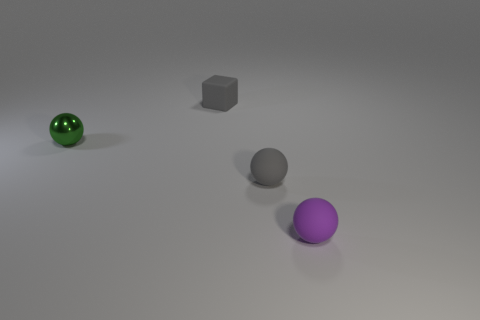How are the shadows affecting the perception of the objects? The shadows cast by the objects help to give a sense of their three-dimensionality and position in the space. They provide clues about the light source direction, which seems to be coming from the top left, and add depth to the image, enhancing the perception of distance between each object. If you had to guess, what material is the ground made of and why? Based on the evenness and matte finish of the ground, it could be made of a neutral, non-reflective material, possibly a synthetic or virtual construct that serves as a neutral background for showcasing the objects without causing any visual distraction. 